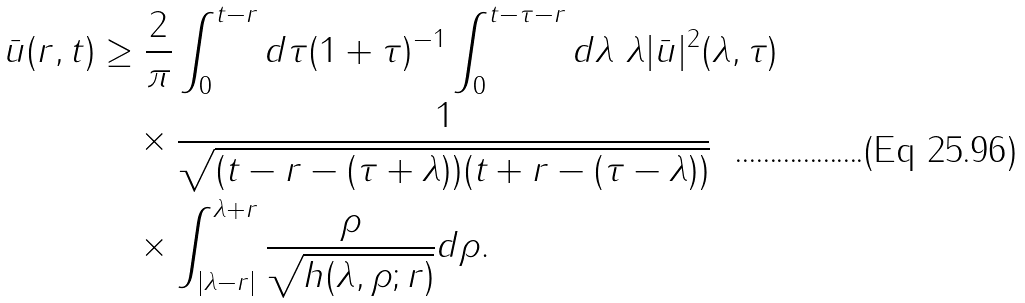Convert formula to latex. <formula><loc_0><loc_0><loc_500><loc_500>\bar { u } ( r , t ) & \geq \frac { 2 } { \pi } \int _ { 0 } ^ { t - r } d \tau ( 1 + \tau ) ^ { - 1 } \int _ { 0 } ^ { t - \tau - r } d \lambda \ \lambda | \bar { u } | ^ { 2 } ( \lambda , \tau ) \\ & \quad \times \frac { 1 } { \sqrt { ( t - r - ( \tau + \lambda ) ) ( t + r - ( \tau - \lambda ) ) } } \\ & \quad \times \int _ { | \lambda - r | } ^ { \lambda + r } \frac { \rho } { \sqrt { h ( \lambda , \rho ; r ) } } d \rho .</formula> 